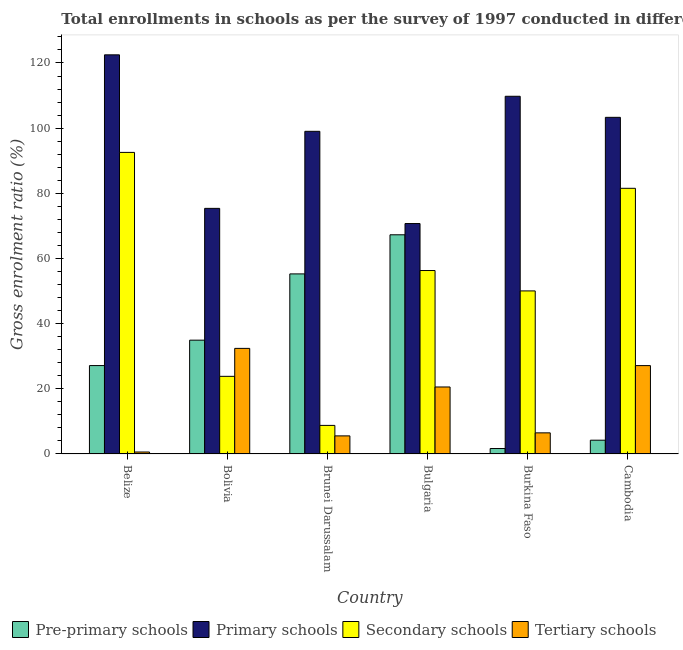How many different coloured bars are there?
Make the answer very short. 4. Are the number of bars per tick equal to the number of legend labels?
Your answer should be very brief. Yes. Are the number of bars on each tick of the X-axis equal?
Your answer should be compact. Yes. What is the label of the 1st group of bars from the left?
Ensure brevity in your answer.  Belize. What is the gross enrolment ratio in primary schools in Cambodia?
Make the answer very short. 103.32. Across all countries, what is the maximum gross enrolment ratio in primary schools?
Offer a very short reply. 122.5. Across all countries, what is the minimum gross enrolment ratio in primary schools?
Your answer should be very brief. 70.72. In which country was the gross enrolment ratio in primary schools maximum?
Your response must be concise. Belize. In which country was the gross enrolment ratio in tertiary schools minimum?
Provide a succinct answer. Belize. What is the total gross enrolment ratio in tertiary schools in the graph?
Offer a terse response. 92.72. What is the difference between the gross enrolment ratio in primary schools in Brunei Darussalam and that in Bulgaria?
Offer a very short reply. 28.3. What is the difference between the gross enrolment ratio in secondary schools in Cambodia and the gross enrolment ratio in pre-primary schools in Bulgaria?
Your response must be concise. 14.26. What is the average gross enrolment ratio in pre-primary schools per country?
Your answer should be very brief. 31.75. What is the difference between the gross enrolment ratio in primary schools and gross enrolment ratio in secondary schools in Brunei Darussalam?
Make the answer very short. 90.25. In how many countries, is the gross enrolment ratio in tertiary schools greater than 40 %?
Offer a terse response. 0. What is the ratio of the gross enrolment ratio in secondary schools in Brunei Darussalam to that in Bulgaria?
Give a very brief answer. 0.16. Is the gross enrolment ratio in secondary schools in Bulgaria less than that in Burkina Faso?
Ensure brevity in your answer.  No. What is the difference between the highest and the second highest gross enrolment ratio in secondary schools?
Your answer should be compact. 11.02. What is the difference between the highest and the lowest gross enrolment ratio in secondary schools?
Give a very brief answer. 83.78. Is the sum of the gross enrolment ratio in tertiary schools in Belize and Bolivia greater than the maximum gross enrolment ratio in primary schools across all countries?
Your response must be concise. No. What does the 2nd bar from the left in Cambodia represents?
Provide a succinct answer. Primary schools. What does the 4th bar from the right in Cambodia represents?
Ensure brevity in your answer.  Pre-primary schools. How many bars are there?
Your answer should be compact. 24. How many countries are there in the graph?
Keep it short and to the point. 6. Where does the legend appear in the graph?
Offer a terse response. Bottom left. What is the title of the graph?
Your response must be concise. Total enrollments in schools as per the survey of 1997 conducted in different countries. What is the label or title of the X-axis?
Keep it short and to the point. Country. What is the label or title of the Y-axis?
Give a very brief answer. Gross enrolment ratio (%). What is the Gross enrolment ratio (%) in Pre-primary schools in Belize?
Your answer should be very brief. 27.13. What is the Gross enrolment ratio (%) in Primary schools in Belize?
Provide a succinct answer. 122.5. What is the Gross enrolment ratio (%) in Secondary schools in Belize?
Provide a succinct answer. 92.55. What is the Gross enrolment ratio (%) in Tertiary schools in Belize?
Make the answer very short. 0.6. What is the Gross enrolment ratio (%) in Pre-primary schools in Bolivia?
Offer a very short reply. 34.93. What is the Gross enrolment ratio (%) in Primary schools in Bolivia?
Provide a succinct answer. 75.38. What is the Gross enrolment ratio (%) of Secondary schools in Bolivia?
Ensure brevity in your answer.  23.83. What is the Gross enrolment ratio (%) of Tertiary schools in Bolivia?
Keep it short and to the point. 32.4. What is the Gross enrolment ratio (%) in Pre-primary schools in Brunei Darussalam?
Provide a succinct answer. 55.27. What is the Gross enrolment ratio (%) of Primary schools in Brunei Darussalam?
Provide a succinct answer. 99.02. What is the Gross enrolment ratio (%) of Secondary schools in Brunei Darussalam?
Provide a short and direct response. 8.77. What is the Gross enrolment ratio (%) in Tertiary schools in Brunei Darussalam?
Ensure brevity in your answer.  5.55. What is the Gross enrolment ratio (%) of Pre-primary schools in Bulgaria?
Your answer should be very brief. 67.27. What is the Gross enrolment ratio (%) of Primary schools in Bulgaria?
Your answer should be very brief. 70.72. What is the Gross enrolment ratio (%) in Secondary schools in Bulgaria?
Your answer should be compact. 56.3. What is the Gross enrolment ratio (%) of Tertiary schools in Bulgaria?
Keep it short and to the point. 20.56. What is the Gross enrolment ratio (%) of Pre-primary schools in Burkina Faso?
Make the answer very short. 1.67. What is the Gross enrolment ratio (%) of Primary schools in Burkina Faso?
Offer a terse response. 109.78. What is the Gross enrolment ratio (%) of Secondary schools in Burkina Faso?
Offer a terse response. 50.04. What is the Gross enrolment ratio (%) in Tertiary schools in Burkina Faso?
Ensure brevity in your answer.  6.48. What is the Gross enrolment ratio (%) of Pre-primary schools in Cambodia?
Offer a very short reply. 4.23. What is the Gross enrolment ratio (%) in Primary schools in Cambodia?
Offer a very short reply. 103.32. What is the Gross enrolment ratio (%) in Secondary schools in Cambodia?
Your response must be concise. 81.53. What is the Gross enrolment ratio (%) in Tertiary schools in Cambodia?
Your response must be concise. 27.12. Across all countries, what is the maximum Gross enrolment ratio (%) in Pre-primary schools?
Your answer should be very brief. 67.27. Across all countries, what is the maximum Gross enrolment ratio (%) in Primary schools?
Offer a terse response. 122.5. Across all countries, what is the maximum Gross enrolment ratio (%) of Secondary schools?
Ensure brevity in your answer.  92.55. Across all countries, what is the maximum Gross enrolment ratio (%) in Tertiary schools?
Your response must be concise. 32.4. Across all countries, what is the minimum Gross enrolment ratio (%) of Pre-primary schools?
Offer a terse response. 1.67. Across all countries, what is the minimum Gross enrolment ratio (%) of Primary schools?
Your response must be concise. 70.72. Across all countries, what is the minimum Gross enrolment ratio (%) in Secondary schools?
Keep it short and to the point. 8.77. Across all countries, what is the minimum Gross enrolment ratio (%) of Tertiary schools?
Provide a succinct answer. 0.6. What is the total Gross enrolment ratio (%) of Pre-primary schools in the graph?
Give a very brief answer. 190.49. What is the total Gross enrolment ratio (%) of Primary schools in the graph?
Provide a succinct answer. 580.73. What is the total Gross enrolment ratio (%) in Secondary schools in the graph?
Offer a very short reply. 313.03. What is the total Gross enrolment ratio (%) of Tertiary schools in the graph?
Offer a terse response. 92.72. What is the difference between the Gross enrolment ratio (%) of Pre-primary schools in Belize and that in Bolivia?
Your answer should be very brief. -7.79. What is the difference between the Gross enrolment ratio (%) of Primary schools in Belize and that in Bolivia?
Your response must be concise. 47.12. What is the difference between the Gross enrolment ratio (%) of Secondary schools in Belize and that in Bolivia?
Provide a succinct answer. 68.73. What is the difference between the Gross enrolment ratio (%) in Tertiary schools in Belize and that in Bolivia?
Your response must be concise. -31.8. What is the difference between the Gross enrolment ratio (%) of Pre-primary schools in Belize and that in Brunei Darussalam?
Keep it short and to the point. -28.13. What is the difference between the Gross enrolment ratio (%) in Primary schools in Belize and that in Brunei Darussalam?
Your response must be concise. 23.48. What is the difference between the Gross enrolment ratio (%) in Secondary schools in Belize and that in Brunei Darussalam?
Provide a short and direct response. 83.78. What is the difference between the Gross enrolment ratio (%) of Tertiary schools in Belize and that in Brunei Darussalam?
Keep it short and to the point. -4.95. What is the difference between the Gross enrolment ratio (%) in Pre-primary schools in Belize and that in Bulgaria?
Make the answer very short. -40.14. What is the difference between the Gross enrolment ratio (%) of Primary schools in Belize and that in Bulgaria?
Give a very brief answer. 51.78. What is the difference between the Gross enrolment ratio (%) of Secondary schools in Belize and that in Bulgaria?
Give a very brief answer. 36.25. What is the difference between the Gross enrolment ratio (%) in Tertiary schools in Belize and that in Bulgaria?
Your response must be concise. -19.96. What is the difference between the Gross enrolment ratio (%) in Pre-primary schools in Belize and that in Burkina Faso?
Give a very brief answer. 25.46. What is the difference between the Gross enrolment ratio (%) of Primary schools in Belize and that in Burkina Faso?
Ensure brevity in your answer.  12.72. What is the difference between the Gross enrolment ratio (%) of Secondary schools in Belize and that in Burkina Faso?
Keep it short and to the point. 42.51. What is the difference between the Gross enrolment ratio (%) of Tertiary schools in Belize and that in Burkina Faso?
Keep it short and to the point. -5.88. What is the difference between the Gross enrolment ratio (%) of Pre-primary schools in Belize and that in Cambodia?
Offer a terse response. 22.91. What is the difference between the Gross enrolment ratio (%) of Primary schools in Belize and that in Cambodia?
Your answer should be very brief. 19.18. What is the difference between the Gross enrolment ratio (%) of Secondary schools in Belize and that in Cambodia?
Give a very brief answer. 11.02. What is the difference between the Gross enrolment ratio (%) in Tertiary schools in Belize and that in Cambodia?
Your answer should be compact. -26.52. What is the difference between the Gross enrolment ratio (%) of Pre-primary schools in Bolivia and that in Brunei Darussalam?
Give a very brief answer. -20.34. What is the difference between the Gross enrolment ratio (%) of Primary schools in Bolivia and that in Brunei Darussalam?
Make the answer very short. -23.64. What is the difference between the Gross enrolment ratio (%) in Secondary schools in Bolivia and that in Brunei Darussalam?
Keep it short and to the point. 15.06. What is the difference between the Gross enrolment ratio (%) of Tertiary schools in Bolivia and that in Brunei Darussalam?
Give a very brief answer. 26.85. What is the difference between the Gross enrolment ratio (%) of Pre-primary schools in Bolivia and that in Bulgaria?
Keep it short and to the point. -32.34. What is the difference between the Gross enrolment ratio (%) of Primary schools in Bolivia and that in Bulgaria?
Make the answer very short. 4.66. What is the difference between the Gross enrolment ratio (%) in Secondary schools in Bolivia and that in Bulgaria?
Offer a very short reply. -32.48. What is the difference between the Gross enrolment ratio (%) of Tertiary schools in Bolivia and that in Bulgaria?
Offer a very short reply. 11.85. What is the difference between the Gross enrolment ratio (%) of Pre-primary schools in Bolivia and that in Burkina Faso?
Your response must be concise. 33.25. What is the difference between the Gross enrolment ratio (%) in Primary schools in Bolivia and that in Burkina Faso?
Your answer should be compact. -34.4. What is the difference between the Gross enrolment ratio (%) in Secondary schools in Bolivia and that in Burkina Faso?
Your answer should be very brief. -26.22. What is the difference between the Gross enrolment ratio (%) of Tertiary schools in Bolivia and that in Burkina Faso?
Keep it short and to the point. 25.92. What is the difference between the Gross enrolment ratio (%) in Pre-primary schools in Bolivia and that in Cambodia?
Your answer should be very brief. 30.7. What is the difference between the Gross enrolment ratio (%) in Primary schools in Bolivia and that in Cambodia?
Offer a very short reply. -27.94. What is the difference between the Gross enrolment ratio (%) in Secondary schools in Bolivia and that in Cambodia?
Make the answer very short. -57.71. What is the difference between the Gross enrolment ratio (%) in Tertiary schools in Bolivia and that in Cambodia?
Provide a short and direct response. 5.28. What is the difference between the Gross enrolment ratio (%) of Pre-primary schools in Brunei Darussalam and that in Bulgaria?
Your response must be concise. -12. What is the difference between the Gross enrolment ratio (%) of Primary schools in Brunei Darussalam and that in Bulgaria?
Your response must be concise. 28.3. What is the difference between the Gross enrolment ratio (%) in Secondary schools in Brunei Darussalam and that in Bulgaria?
Make the answer very short. -47.53. What is the difference between the Gross enrolment ratio (%) of Tertiary schools in Brunei Darussalam and that in Bulgaria?
Make the answer very short. -15.01. What is the difference between the Gross enrolment ratio (%) of Pre-primary schools in Brunei Darussalam and that in Burkina Faso?
Ensure brevity in your answer.  53.59. What is the difference between the Gross enrolment ratio (%) in Primary schools in Brunei Darussalam and that in Burkina Faso?
Make the answer very short. -10.76. What is the difference between the Gross enrolment ratio (%) in Secondary schools in Brunei Darussalam and that in Burkina Faso?
Your response must be concise. -41.27. What is the difference between the Gross enrolment ratio (%) in Tertiary schools in Brunei Darussalam and that in Burkina Faso?
Keep it short and to the point. -0.93. What is the difference between the Gross enrolment ratio (%) of Pre-primary schools in Brunei Darussalam and that in Cambodia?
Offer a very short reply. 51.04. What is the difference between the Gross enrolment ratio (%) of Primary schools in Brunei Darussalam and that in Cambodia?
Your response must be concise. -4.29. What is the difference between the Gross enrolment ratio (%) in Secondary schools in Brunei Darussalam and that in Cambodia?
Offer a very short reply. -72.76. What is the difference between the Gross enrolment ratio (%) in Tertiary schools in Brunei Darussalam and that in Cambodia?
Your answer should be very brief. -21.57. What is the difference between the Gross enrolment ratio (%) of Pre-primary schools in Bulgaria and that in Burkina Faso?
Your response must be concise. 65.6. What is the difference between the Gross enrolment ratio (%) of Primary schools in Bulgaria and that in Burkina Faso?
Keep it short and to the point. -39.06. What is the difference between the Gross enrolment ratio (%) of Secondary schools in Bulgaria and that in Burkina Faso?
Keep it short and to the point. 6.26. What is the difference between the Gross enrolment ratio (%) in Tertiary schools in Bulgaria and that in Burkina Faso?
Provide a short and direct response. 14.08. What is the difference between the Gross enrolment ratio (%) of Pre-primary schools in Bulgaria and that in Cambodia?
Your response must be concise. 63.04. What is the difference between the Gross enrolment ratio (%) of Primary schools in Bulgaria and that in Cambodia?
Your answer should be compact. -32.59. What is the difference between the Gross enrolment ratio (%) of Secondary schools in Bulgaria and that in Cambodia?
Ensure brevity in your answer.  -25.23. What is the difference between the Gross enrolment ratio (%) in Tertiary schools in Bulgaria and that in Cambodia?
Your answer should be very brief. -6.56. What is the difference between the Gross enrolment ratio (%) of Pre-primary schools in Burkina Faso and that in Cambodia?
Offer a very short reply. -2.55. What is the difference between the Gross enrolment ratio (%) in Primary schools in Burkina Faso and that in Cambodia?
Your answer should be very brief. 6.47. What is the difference between the Gross enrolment ratio (%) of Secondary schools in Burkina Faso and that in Cambodia?
Your answer should be compact. -31.49. What is the difference between the Gross enrolment ratio (%) of Tertiary schools in Burkina Faso and that in Cambodia?
Give a very brief answer. -20.64. What is the difference between the Gross enrolment ratio (%) of Pre-primary schools in Belize and the Gross enrolment ratio (%) of Primary schools in Bolivia?
Offer a terse response. -48.25. What is the difference between the Gross enrolment ratio (%) in Pre-primary schools in Belize and the Gross enrolment ratio (%) in Secondary schools in Bolivia?
Make the answer very short. 3.31. What is the difference between the Gross enrolment ratio (%) in Pre-primary schools in Belize and the Gross enrolment ratio (%) in Tertiary schools in Bolivia?
Ensure brevity in your answer.  -5.27. What is the difference between the Gross enrolment ratio (%) in Primary schools in Belize and the Gross enrolment ratio (%) in Secondary schools in Bolivia?
Provide a short and direct response. 98.67. What is the difference between the Gross enrolment ratio (%) of Primary schools in Belize and the Gross enrolment ratio (%) of Tertiary schools in Bolivia?
Provide a short and direct response. 90.1. What is the difference between the Gross enrolment ratio (%) of Secondary schools in Belize and the Gross enrolment ratio (%) of Tertiary schools in Bolivia?
Your response must be concise. 60.15. What is the difference between the Gross enrolment ratio (%) of Pre-primary schools in Belize and the Gross enrolment ratio (%) of Primary schools in Brunei Darussalam?
Provide a succinct answer. -71.89. What is the difference between the Gross enrolment ratio (%) in Pre-primary schools in Belize and the Gross enrolment ratio (%) in Secondary schools in Brunei Darussalam?
Offer a very short reply. 18.36. What is the difference between the Gross enrolment ratio (%) of Pre-primary schools in Belize and the Gross enrolment ratio (%) of Tertiary schools in Brunei Darussalam?
Provide a succinct answer. 21.58. What is the difference between the Gross enrolment ratio (%) in Primary schools in Belize and the Gross enrolment ratio (%) in Secondary schools in Brunei Darussalam?
Your answer should be very brief. 113.73. What is the difference between the Gross enrolment ratio (%) in Primary schools in Belize and the Gross enrolment ratio (%) in Tertiary schools in Brunei Darussalam?
Keep it short and to the point. 116.95. What is the difference between the Gross enrolment ratio (%) of Secondary schools in Belize and the Gross enrolment ratio (%) of Tertiary schools in Brunei Darussalam?
Provide a succinct answer. 87. What is the difference between the Gross enrolment ratio (%) of Pre-primary schools in Belize and the Gross enrolment ratio (%) of Primary schools in Bulgaria?
Offer a terse response. -43.59. What is the difference between the Gross enrolment ratio (%) of Pre-primary schools in Belize and the Gross enrolment ratio (%) of Secondary schools in Bulgaria?
Offer a very short reply. -29.17. What is the difference between the Gross enrolment ratio (%) of Pre-primary schools in Belize and the Gross enrolment ratio (%) of Tertiary schools in Bulgaria?
Your answer should be compact. 6.57. What is the difference between the Gross enrolment ratio (%) of Primary schools in Belize and the Gross enrolment ratio (%) of Secondary schools in Bulgaria?
Offer a very short reply. 66.2. What is the difference between the Gross enrolment ratio (%) in Primary schools in Belize and the Gross enrolment ratio (%) in Tertiary schools in Bulgaria?
Provide a short and direct response. 101.94. What is the difference between the Gross enrolment ratio (%) in Secondary schools in Belize and the Gross enrolment ratio (%) in Tertiary schools in Bulgaria?
Offer a terse response. 72. What is the difference between the Gross enrolment ratio (%) of Pre-primary schools in Belize and the Gross enrolment ratio (%) of Primary schools in Burkina Faso?
Your answer should be compact. -82.65. What is the difference between the Gross enrolment ratio (%) of Pre-primary schools in Belize and the Gross enrolment ratio (%) of Secondary schools in Burkina Faso?
Your answer should be compact. -22.91. What is the difference between the Gross enrolment ratio (%) in Pre-primary schools in Belize and the Gross enrolment ratio (%) in Tertiary schools in Burkina Faso?
Your answer should be compact. 20.65. What is the difference between the Gross enrolment ratio (%) in Primary schools in Belize and the Gross enrolment ratio (%) in Secondary schools in Burkina Faso?
Your answer should be very brief. 72.46. What is the difference between the Gross enrolment ratio (%) in Primary schools in Belize and the Gross enrolment ratio (%) in Tertiary schools in Burkina Faso?
Make the answer very short. 116.02. What is the difference between the Gross enrolment ratio (%) in Secondary schools in Belize and the Gross enrolment ratio (%) in Tertiary schools in Burkina Faso?
Ensure brevity in your answer.  86.07. What is the difference between the Gross enrolment ratio (%) of Pre-primary schools in Belize and the Gross enrolment ratio (%) of Primary schools in Cambodia?
Offer a very short reply. -76.18. What is the difference between the Gross enrolment ratio (%) of Pre-primary schools in Belize and the Gross enrolment ratio (%) of Secondary schools in Cambodia?
Your response must be concise. -54.4. What is the difference between the Gross enrolment ratio (%) in Pre-primary schools in Belize and the Gross enrolment ratio (%) in Tertiary schools in Cambodia?
Your answer should be very brief. 0.01. What is the difference between the Gross enrolment ratio (%) in Primary schools in Belize and the Gross enrolment ratio (%) in Secondary schools in Cambodia?
Provide a short and direct response. 40.97. What is the difference between the Gross enrolment ratio (%) in Primary schools in Belize and the Gross enrolment ratio (%) in Tertiary schools in Cambodia?
Your answer should be very brief. 95.38. What is the difference between the Gross enrolment ratio (%) of Secondary schools in Belize and the Gross enrolment ratio (%) of Tertiary schools in Cambodia?
Keep it short and to the point. 65.43. What is the difference between the Gross enrolment ratio (%) in Pre-primary schools in Bolivia and the Gross enrolment ratio (%) in Primary schools in Brunei Darussalam?
Your answer should be very brief. -64.1. What is the difference between the Gross enrolment ratio (%) of Pre-primary schools in Bolivia and the Gross enrolment ratio (%) of Secondary schools in Brunei Darussalam?
Your response must be concise. 26.16. What is the difference between the Gross enrolment ratio (%) of Pre-primary schools in Bolivia and the Gross enrolment ratio (%) of Tertiary schools in Brunei Darussalam?
Give a very brief answer. 29.38. What is the difference between the Gross enrolment ratio (%) of Primary schools in Bolivia and the Gross enrolment ratio (%) of Secondary schools in Brunei Darussalam?
Give a very brief answer. 66.61. What is the difference between the Gross enrolment ratio (%) in Primary schools in Bolivia and the Gross enrolment ratio (%) in Tertiary schools in Brunei Darussalam?
Keep it short and to the point. 69.83. What is the difference between the Gross enrolment ratio (%) in Secondary schools in Bolivia and the Gross enrolment ratio (%) in Tertiary schools in Brunei Darussalam?
Ensure brevity in your answer.  18.28. What is the difference between the Gross enrolment ratio (%) in Pre-primary schools in Bolivia and the Gross enrolment ratio (%) in Primary schools in Bulgaria?
Your answer should be compact. -35.79. What is the difference between the Gross enrolment ratio (%) of Pre-primary schools in Bolivia and the Gross enrolment ratio (%) of Secondary schools in Bulgaria?
Your answer should be very brief. -21.37. What is the difference between the Gross enrolment ratio (%) in Pre-primary schools in Bolivia and the Gross enrolment ratio (%) in Tertiary schools in Bulgaria?
Your response must be concise. 14.37. What is the difference between the Gross enrolment ratio (%) in Primary schools in Bolivia and the Gross enrolment ratio (%) in Secondary schools in Bulgaria?
Offer a very short reply. 19.08. What is the difference between the Gross enrolment ratio (%) in Primary schools in Bolivia and the Gross enrolment ratio (%) in Tertiary schools in Bulgaria?
Your response must be concise. 54.82. What is the difference between the Gross enrolment ratio (%) in Secondary schools in Bolivia and the Gross enrolment ratio (%) in Tertiary schools in Bulgaria?
Your answer should be very brief. 3.27. What is the difference between the Gross enrolment ratio (%) in Pre-primary schools in Bolivia and the Gross enrolment ratio (%) in Primary schools in Burkina Faso?
Offer a terse response. -74.86. What is the difference between the Gross enrolment ratio (%) of Pre-primary schools in Bolivia and the Gross enrolment ratio (%) of Secondary schools in Burkina Faso?
Make the answer very short. -15.12. What is the difference between the Gross enrolment ratio (%) of Pre-primary schools in Bolivia and the Gross enrolment ratio (%) of Tertiary schools in Burkina Faso?
Offer a terse response. 28.45. What is the difference between the Gross enrolment ratio (%) in Primary schools in Bolivia and the Gross enrolment ratio (%) in Secondary schools in Burkina Faso?
Give a very brief answer. 25.34. What is the difference between the Gross enrolment ratio (%) of Primary schools in Bolivia and the Gross enrolment ratio (%) of Tertiary schools in Burkina Faso?
Provide a succinct answer. 68.9. What is the difference between the Gross enrolment ratio (%) of Secondary schools in Bolivia and the Gross enrolment ratio (%) of Tertiary schools in Burkina Faso?
Provide a short and direct response. 17.35. What is the difference between the Gross enrolment ratio (%) of Pre-primary schools in Bolivia and the Gross enrolment ratio (%) of Primary schools in Cambodia?
Ensure brevity in your answer.  -68.39. What is the difference between the Gross enrolment ratio (%) in Pre-primary schools in Bolivia and the Gross enrolment ratio (%) in Secondary schools in Cambodia?
Provide a succinct answer. -46.61. What is the difference between the Gross enrolment ratio (%) of Pre-primary schools in Bolivia and the Gross enrolment ratio (%) of Tertiary schools in Cambodia?
Offer a terse response. 7.8. What is the difference between the Gross enrolment ratio (%) in Primary schools in Bolivia and the Gross enrolment ratio (%) in Secondary schools in Cambodia?
Keep it short and to the point. -6.15. What is the difference between the Gross enrolment ratio (%) of Primary schools in Bolivia and the Gross enrolment ratio (%) of Tertiary schools in Cambodia?
Ensure brevity in your answer.  48.26. What is the difference between the Gross enrolment ratio (%) in Secondary schools in Bolivia and the Gross enrolment ratio (%) in Tertiary schools in Cambodia?
Offer a very short reply. -3.3. What is the difference between the Gross enrolment ratio (%) in Pre-primary schools in Brunei Darussalam and the Gross enrolment ratio (%) in Primary schools in Bulgaria?
Keep it short and to the point. -15.46. What is the difference between the Gross enrolment ratio (%) of Pre-primary schools in Brunei Darussalam and the Gross enrolment ratio (%) of Secondary schools in Bulgaria?
Offer a very short reply. -1.04. What is the difference between the Gross enrolment ratio (%) in Pre-primary schools in Brunei Darussalam and the Gross enrolment ratio (%) in Tertiary schools in Bulgaria?
Offer a terse response. 34.71. What is the difference between the Gross enrolment ratio (%) in Primary schools in Brunei Darussalam and the Gross enrolment ratio (%) in Secondary schools in Bulgaria?
Ensure brevity in your answer.  42.72. What is the difference between the Gross enrolment ratio (%) of Primary schools in Brunei Darussalam and the Gross enrolment ratio (%) of Tertiary schools in Bulgaria?
Ensure brevity in your answer.  78.46. What is the difference between the Gross enrolment ratio (%) of Secondary schools in Brunei Darussalam and the Gross enrolment ratio (%) of Tertiary schools in Bulgaria?
Provide a short and direct response. -11.79. What is the difference between the Gross enrolment ratio (%) of Pre-primary schools in Brunei Darussalam and the Gross enrolment ratio (%) of Primary schools in Burkina Faso?
Provide a succinct answer. -54.52. What is the difference between the Gross enrolment ratio (%) of Pre-primary schools in Brunei Darussalam and the Gross enrolment ratio (%) of Secondary schools in Burkina Faso?
Your response must be concise. 5.22. What is the difference between the Gross enrolment ratio (%) in Pre-primary schools in Brunei Darussalam and the Gross enrolment ratio (%) in Tertiary schools in Burkina Faso?
Give a very brief answer. 48.79. What is the difference between the Gross enrolment ratio (%) of Primary schools in Brunei Darussalam and the Gross enrolment ratio (%) of Secondary schools in Burkina Faso?
Provide a succinct answer. 48.98. What is the difference between the Gross enrolment ratio (%) of Primary schools in Brunei Darussalam and the Gross enrolment ratio (%) of Tertiary schools in Burkina Faso?
Give a very brief answer. 92.54. What is the difference between the Gross enrolment ratio (%) in Secondary schools in Brunei Darussalam and the Gross enrolment ratio (%) in Tertiary schools in Burkina Faso?
Offer a terse response. 2.29. What is the difference between the Gross enrolment ratio (%) of Pre-primary schools in Brunei Darussalam and the Gross enrolment ratio (%) of Primary schools in Cambodia?
Make the answer very short. -48.05. What is the difference between the Gross enrolment ratio (%) in Pre-primary schools in Brunei Darussalam and the Gross enrolment ratio (%) in Secondary schools in Cambodia?
Ensure brevity in your answer.  -26.27. What is the difference between the Gross enrolment ratio (%) in Pre-primary schools in Brunei Darussalam and the Gross enrolment ratio (%) in Tertiary schools in Cambodia?
Keep it short and to the point. 28.14. What is the difference between the Gross enrolment ratio (%) in Primary schools in Brunei Darussalam and the Gross enrolment ratio (%) in Secondary schools in Cambodia?
Offer a very short reply. 17.49. What is the difference between the Gross enrolment ratio (%) of Primary schools in Brunei Darussalam and the Gross enrolment ratio (%) of Tertiary schools in Cambodia?
Give a very brief answer. 71.9. What is the difference between the Gross enrolment ratio (%) of Secondary schools in Brunei Darussalam and the Gross enrolment ratio (%) of Tertiary schools in Cambodia?
Ensure brevity in your answer.  -18.35. What is the difference between the Gross enrolment ratio (%) of Pre-primary schools in Bulgaria and the Gross enrolment ratio (%) of Primary schools in Burkina Faso?
Your response must be concise. -42.51. What is the difference between the Gross enrolment ratio (%) in Pre-primary schools in Bulgaria and the Gross enrolment ratio (%) in Secondary schools in Burkina Faso?
Provide a succinct answer. 17.23. What is the difference between the Gross enrolment ratio (%) in Pre-primary schools in Bulgaria and the Gross enrolment ratio (%) in Tertiary schools in Burkina Faso?
Your answer should be compact. 60.79. What is the difference between the Gross enrolment ratio (%) in Primary schools in Bulgaria and the Gross enrolment ratio (%) in Secondary schools in Burkina Faso?
Keep it short and to the point. 20.68. What is the difference between the Gross enrolment ratio (%) in Primary schools in Bulgaria and the Gross enrolment ratio (%) in Tertiary schools in Burkina Faso?
Your answer should be compact. 64.24. What is the difference between the Gross enrolment ratio (%) of Secondary schools in Bulgaria and the Gross enrolment ratio (%) of Tertiary schools in Burkina Faso?
Make the answer very short. 49.82. What is the difference between the Gross enrolment ratio (%) in Pre-primary schools in Bulgaria and the Gross enrolment ratio (%) in Primary schools in Cambodia?
Your response must be concise. -36.05. What is the difference between the Gross enrolment ratio (%) of Pre-primary schools in Bulgaria and the Gross enrolment ratio (%) of Secondary schools in Cambodia?
Provide a short and direct response. -14.26. What is the difference between the Gross enrolment ratio (%) in Pre-primary schools in Bulgaria and the Gross enrolment ratio (%) in Tertiary schools in Cambodia?
Offer a very short reply. 40.15. What is the difference between the Gross enrolment ratio (%) of Primary schools in Bulgaria and the Gross enrolment ratio (%) of Secondary schools in Cambodia?
Offer a terse response. -10.81. What is the difference between the Gross enrolment ratio (%) in Primary schools in Bulgaria and the Gross enrolment ratio (%) in Tertiary schools in Cambodia?
Your response must be concise. 43.6. What is the difference between the Gross enrolment ratio (%) in Secondary schools in Bulgaria and the Gross enrolment ratio (%) in Tertiary schools in Cambodia?
Ensure brevity in your answer.  29.18. What is the difference between the Gross enrolment ratio (%) of Pre-primary schools in Burkina Faso and the Gross enrolment ratio (%) of Primary schools in Cambodia?
Make the answer very short. -101.64. What is the difference between the Gross enrolment ratio (%) of Pre-primary schools in Burkina Faso and the Gross enrolment ratio (%) of Secondary schools in Cambodia?
Your answer should be very brief. -79.86. What is the difference between the Gross enrolment ratio (%) of Pre-primary schools in Burkina Faso and the Gross enrolment ratio (%) of Tertiary schools in Cambodia?
Offer a terse response. -25.45. What is the difference between the Gross enrolment ratio (%) in Primary schools in Burkina Faso and the Gross enrolment ratio (%) in Secondary schools in Cambodia?
Give a very brief answer. 28.25. What is the difference between the Gross enrolment ratio (%) in Primary schools in Burkina Faso and the Gross enrolment ratio (%) in Tertiary schools in Cambodia?
Ensure brevity in your answer.  82.66. What is the difference between the Gross enrolment ratio (%) in Secondary schools in Burkina Faso and the Gross enrolment ratio (%) in Tertiary schools in Cambodia?
Give a very brief answer. 22.92. What is the average Gross enrolment ratio (%) of Pre-primary schools per country?
Give a very brief answer. 31.75. What is the average Gross enrolment ratio (%) in Primary schools per country?
Ensure brevity in your answer.  96.79. What is the average Gross enrolment ratio (%) in Secondary schools per country?
Offer a very short reply. 52.17. What is the average Gross enrolment ratio (%) of Tertiary schools per country?
Offer a very short reply. 15.45. What is the difference between the Gross enrolment ratio (%) of Pre-primary schools and Gross enrolment ratio (%) of Primary schools in Belize?
Provide a short and direct response. -95.37. What is the difference between the Gross enrolment ratio (%) of Pre-primary schools and Gross enrolment ratio (%) of Secondary schools in Belize?
Your answer should be very brief. -65.42. What is the difference between the Gross enrolment ratio (%) of Pre-primary schools and Gross enrolment ratio (%) of Tertiary schools in Belize?
Provide a short and direct response. 26.53. What is the difference between the Gross enrolment ratio (%) in Primary schools and Gross enrolment ratio (%) in Secondary schools in Belize?
Provide a succinct answer. 29.95. What is the difference between the Gross enrolment ratio (%) in Primary schools and Gross enrolment ratio (%) in Tertiary schools in Belize?
Your response must be concise. 121.9. What is the difference between the Gross enrolment ratio (%) in Secondary schools and Gross enrolment ratio (%) in Tertiary schools in Belize?
Provide a succinct answer. 91.95. What is the difference between the Gross enrolment ratio (%) of Pre-primary schools and Gross enrolment ratio (%) of Primary schools in Bolivia?
Offer a terse response. -40.45. What is the difference between the Gross enrolment ratio (%) in Pre-primary schools and Gross enrolment ratio (%) in Secondary schools in Bolivia?
Offer a very short reply. 11.1. What is the difference between the Gross enrolment ratio (%) in Pre-primary schools and Gross enrolment ratio (%) in Tertiary schools in Bolivia?
Offer a terse response. 2.52. What is the difference between the Gross enrolment ratio (%) in Primary schools and Gross enrolment ratio (%) in Secondary schools in Bolivia?
Offer a terse response. 51.55. What is the difference between the Gross enrolment ratio (%) in Primary schools and Gross enrolment ratio (%) in Tertiary schools in Bolivia?
Give a very brief answer. 42.98. What is the difference between the Gross enrolment ratio (%) of Secondary schools and Gross enrolment ratio (%) of Tertiary schools in Bolivia?
Provide a succinct answer. -8.58. What is the difference between the Gross enrolment ratio (%) in Pre-primary schools and Gross enrolment ratio (%) in Primary schools in Brunei Darussalam?
Offer a very short reply. -43.76. What is the difference between the Gross enrolment ratio (%) in Pre-primary schools and Gross enrolment ratio (%) in Secondary schools in Brunei Darussalam?
Provide a succinct answer. 46.49. What is the difference between the Gross enrolment ratio (%) of Pre-primary schools and Gross enrolment ratio (%) of Tertiary schools in Brunei Darussalam?
Your answer should be compact. 49.71. What is the difference between the Gross enrolment ratio (%) in Primary schools and Gross enrolment ratio (%) in Secondary schools in Brunei Darussalam?
Your response must be concise. 90.25. What is the difference between the Gross enrolment ratio (%) of Primary schools and Gross enrolment ratio (%) of Tertiary schools in Brunei Darussalam?
Keep it short and to the point. 93.47. What is the difference between the Gross enrolment ratio (%) in Secondary schools and Gross enrolment ratio (%) in Tertiary schools in Brunei Darussalam?
Offer a very short reply. 3.22. What is the difference between the Gross enrolment ratio (%) of Pre-primary schools and Gross enrolment ratio (%) of Primary schools in Bulgaria?
Your answer should be very brief. -3.45. What is the difference between the Gross enrolment ratio (%) of Pre-primary schools and Gross enrolment ratio (%) of Secondary schools in Bulgaria?
Provide a short and direct response. 10.97. What is the difference between the Gross enrolment ratio (%) in Pre-primary schools and Gross enrolment ratio (%) in Tertiary schools in Bulgaria?
Your answer should be very brief. 46.71. What is the difference between the Gross enrolment ratio (%) of Primary schools and Gross enrolment ratio (%) of Secondary schools in Bulgaria?
Your response must be concise. 14.42. What is the difference between the Gross enrolment ratio (%) of Primary schools and Gross enrolment ratio (%) of Tertiary schools in Bulgaria?
Give a very brief answer. 50.16. What is the difference between the Gross enrolment ratio (%) in Secondary schools and Gross enrolment ratio (%) in Tertiary schools in Bulgaria?
Your answer should be compact. 35.74. What is the difference between the Gross enrolment ratio (%) of Pre-primary schools and Gross enrolment ratio (%) of Primary schools in Burkina Faso?
Provide a succinct answer. -108.11. What is the difference between the Gross enrolment ratio (%) in Pre-primary schools and Gross enrolment ratio (%) in Secondary schools in Burkina Faso?
Your response must be concise. -48.37. What is the difference between the Gross enrolment ratio (%) of Pre-primary schools and Gross enrolment ratio (%) of Tertiary schools in Burkina Faso?
Ensure brevity in your answer.  -4.81. What is the difference between the Gross enrolment ratio (%) in Primary schools and Gross enrolment ratio (%) in Secondary schools in Burkina Faso?
Offer a terse response. 59.74. What is the difference between the Gross enrolment ratio (%) of Primary schools and Gross enrolment ratio (%) of Tertiary schools in Burkina Faso?
Give a very brief answer. 103.3. What is the difference between the Gross enrolment ratio (%) in Secondary schools and Gross enrolment ratio (%) in Tertiary schools in Burkina Faso?
Provide a short and direct response. 43.56. What is the difference between the Gross enrolment ratio (%) of Pre-primary schools and Gross enrolment ratio (%) of Primary schools in Cambodia?
Ensure brevity in your answer.  -99.09. What is the difference between the Gross enrolment ratio (%) of Pre-primary schools and Gross enrolment ratio (%) of Secondary schools in Cambodia?
Offer a terse response. -77.31. What is the difference between the Gross enrolment ratio (%) of Pre-primary schools and Gross enrolment ratio (%) of Tertiary schools in Cambodia?
Make the answer very short. -22.9. What is the difference between the Gross enrolment ratio (%) of Primary schools and Gross enrolment ratio (%) of Secondary schools in Cambodia?
Make the answer very short. 21.78. What is the difference between the Gross enrolment ratio (%) in Primary schools and Gross enrolment ratio (%) in Tertiary schools in Cambodia?
Make the answer very short. 76.19. What is the difference between the Gross enrolment ratio (%) of Secondary schools and Gross enrolment ratio (%) of Tertiary schools in Cambodia?
Your answer should be compact. 54.41. What is the ratio of the Gross enrolment ratio (%) of Pre-primary schools in Belize to that in Bolivia?
Your response must be concise. 0.78. What is the ratio of the Gross enrolment ratio (%) in Primary schools in Belize to that in Bolivia?
Keep it short and to the point. 1.63. What is the ratio of the Gross enrolment ratio (%) of Secondary schools in Belize to that in Bolivia?
Make the answer very short. 3.88. What is the ratio of the Gross enrolment ratio (%) of Tertiary schools in Belize to that in Bolivia?
Provide a succinct answer. 0.02. What is the ratio of the Gross enrolment ratio (%) in Pre-primary schools in Belize to that in Brunei Darussalam?
Make the answer very short. 0.49. What is the ratio of the Gross enrolment ratio (%) in Primary schools in Belize to that in Brunei Darussalam?
Provide a succinct answer. 1.24. What is the ratio of the Gross enrolment ratio (%) of Secondary schools in Belize to that in Brunei Darussalam?
Offer a terse response. 10.55. What is the ratio of the Gross enrolment ratio (%) of Tertiary schools in Belize to that in Brunei Darussalam?
Your answer should be compact. 0.11. What is the ratio of the Gross enrolment ratio (%) in Pre-primary schools in Belize to that in Bulgaria?
Provide a succinct answer. 0.4. What is the ratio of the Gross enrolment ratio (%) in Primary schools in Belize to that in Bulgaria?
Make the answer very short. 1.73. What is the ratio of the Gross enrolment ratio (%) in Secondary schools in Belize to that in Bulgaria?
Ensure brevity in your answer.  1.64. What is the ratio of the Gross enrolment ratio (%) in Tertiary schools in Belize to that in Bulgaria?
Make the answer very short. 0.03. What is the ratio of the Gross enrolment ratio (%) in Pre-primary schools in Belize to that in Burkina Faso?
Keep it short and to the point. 16.23. What is the ratio of the Gross enrolment ratio (%) of Primary schools in Belize to that in Burkina Faso?
Offer a very short reply. 1.12. What is the ratio of the Gross enrolment ratio (%) of Secondary schools in Belize to that in Burkina Faso?
Offer a very short reply. 1.85. What is the ratio of the Gross enrolment ratio (%) of Tertiary schools in Belize to that in Burkina Faso?
Offer a very short reply. 0.09. What is the ratio of the Gross enrolment ratio (%) in Pre-primary schools in Belize to that in Cambodia?
Provide a short and direct response. 6.42. What is the ratio of the Gross enrolment ratio (%) of Primary schools in Belize to that in Cambodia?
Keep it short and to the point. 1.19. What is the ratio of the Gross enrolment ratio (%) in Secondary schools in Belize to that in Cambodia?
Offer a terse response. 1.14. What is the ratio of the Gross enrolment ratio (%) in Tertiary schools in Belize to that in Cambodia?
Provide a succinct answer. 0.02. What is the ratio of the Gross enrolment ratio (%) of Pre-primary schools in Bolivia to that in Brunei Darussalam?
Ensure brevity in your answer.  0.63. What is the ratio of the Gross enrolment ratio (%) in Primary schools in Bolivia to that in Brunei Darussalam?
Keep it short and to the point. 0.76. What is the ratio of the Gross enrolment ratio (%) of Secondary schools in Bolivia to that in Brunei Darussalam?
Offer a very short reply. 2.72. What is the ratio of the Gross enrolment ratio (%) in Tertiary schools in Bolivia to that in Brunei Darussalam?
Offer a terse response. 5.84. What is the ratio of the Gross enrolment ratio (%) in Pre-primary schools in Bolivia to that in Bulgaria?
Ensure brevity in your answer.  0.52. What is the ratio of the Gross enrolment ratio (%) of Primary schools in Bolivia to that in Bulgaria?
Provide a succinct answer. 1.07. What is the ratio of the Gross enrolment ratio (%) of Secondary schools in Bolivia to that in Bulgaria?
Your answer should be very brief. 0.42. What is the ratio of the Gross enrolment ratio (%) in Tertiary schools in Bolivia to that in Bulgaria?
Your response must be concise. 1.58. What is the ratio of the Gross enrolment ratio (%) of Pre-primary schools in Bolivia to that in Burkina Faso?
Provide a short and direct response. 20.89. What is the ratio of the Gross enrolment ratio (%) in Primary schools in Bolivia to that in Burkina Faso?
Your answer should be compact. 0.69. What is the ratio of the Gross enrolment ratio (%) of Secondary schools in Bolivia to that in Burkina Faso?
Your response must be concise. 0.48. What is the ratio of the Gross enrolment ratio (%) of Tertiary schools in Bolivia to that in Burkina Faso?
Give a very brief answer. 5. What is the ratio of the Gross enrolment ratio (%) in Pre-primary schools in Bolivia to that in Cambodia?
Your response must be concise. 8.26. What is the ratio of the Gross enrolment ratio (%) in Primary schools in Bolivia to that in Cambodia?
Offer a very short reply. 0.73. What is the ratio of the Gross enrolment ratio (%) of Secondary schools in Bolivia to that in Cambodia?
Your response must be concise. 0.29. What is the ratio of the Gross enrolment ratio (%) of Tertiary schools in Bolivia to that in Cambodia?
Your answer should be very brief. 1.19. What is the ratio of the Gross enrolment ratio (%) of Pre-primary schools in Brunei Darussalam to that in Bulgaria?
Your response must be concise. 0.82. What is the ratio of the Gross enrolment ratio (%) of Primary schools in Brunei Darussalam to that in Bulgaria?
Give a very brief answer. 1.4. What is the ratio of the Gross enrolment ratio (%) of Secondary schools in Brunei Darussalam to that in Bulgaria?
Make the answer very short. 0.16. What is the ratio of the Gross enrolment ratio (%) of Tertiary schools in Brunei Darussalam to that in Bulgaria?
Offer a very short reply. 0.27. What is the ratio of the Gross enrolment ratio (%) in Pre-primary schools in Brunei Darussalam to that in Burkina Faso?
Your answer should be very brief. 33.05. What is the ratio of the Gross enrolment ratio (%) of Primary schools in Brunei Darussalam to that in Burkina Faso?
Offer a terse response. 0.9. What is the ratio of the Gross enrolment ratio (%) of Secondary schools in Brunei Darussalam to that in Burkina Faso?
Offer a very short reply. 0.18. What is the ratio of the Gross enrolment ratio (%) of Tertiary schools in Brunei Darussalam to that in Burkina Faso?
Give a very brief answer. 0.86. What is the ratio of the Gross enrolment ratio (%) in Pre-primary schools in Brunei Darussalam to that in Cambodia?
Your response must be concise. 13.07. What is the ratio of the Gross enrolment ratio (%) in Primary schools in Brunei Darussalam to that in Cambodia?
Offer a very short reply. 0.96. What is the ratio of the Gross enrolment ratio (%) in Secondary schools in Brunei Darussalam to that in Cambodia?
Provide a succinct answer. 0.11. What is the ratio of the Gross enrolment ratio (%) of Tertiary schools in Brunei Darussalam to that in Cambodia?
Give a very brief answer. 0.2. What is the ratio of the Gross enrolment ratio (%) in Pre-primary schools in Bulgaria to that in Burkina Faso?
Your answer should be very brief. 40.23. What is the ratio of the Gross enrolment ratio (%) in Primary schools in Bulgaria to that in Burkina Faso?
Ensure brevity in your answer.  0.64. What is the ratio of the Gross enrolment ratio (%) in Secondary schools in Bulgaria to that in Burkina Faso?
Keep it short and to the point. 1.13. What is the ratio of the Gross enrolment ratio (%) in Tertiary schools in Bulgaria to that in Burkina Faso?
Your response must be concise. 3.17. What is the ratio of the Gross enrolment ratio (%) of Pre-primary schools in Bulgaria to that in Cambodia?
Your response must be concise. 15.91. What is the ratio of the Gross enrolment ratio (%) of Primary schools in Bulgaria to that in Cambodia?
Your response must be concise. 0.68. What is the ratio of the Gross enrolment ratio (%) of Secondary schools in Bulgaria to that in Cambodia?
Offer a terse response. 0.69. What is the ratio of the Gross enrolment ratio (%) in Tertiary schools in Bulgaria to that in Cambodia?
Keep it short and to the point. 0.76. What is the ratio of the Gross enrolment ratio (%) of Pre-primary schools in Burkina Faso to that in Cambodia?
Make the answer very short. 0.4. What is the ratio of the Gross enrolment ratio (%) in Primary schools in Burkina Faso to that in Cambodia?
Keep it short and to the point. 1.06. What is the ratio of the Gross enrolment ratio (%) of Secondary schools in Burkina Faso to that in Cambodia?
Your answer should be compact. 0.61. What is the ratio of the Gross enrolment ratio (%) of Tertiary schools in Burkina Faso to that in Cambodia?
Offer a terse response. 0.24. What is the difference between the highest and the second highest Gross enrolment ratio (%) of Pre-primary schools?
Your answer should be very brief. 12. What is the difference between the highest and the second highest Gross enrolment ratio (%) of Primary schools?
Ensure brevity in your answer.  12.72. What is the difference between the highest and the second highest Gross enrolment ratio (%) of Secondary schools?
Your response must be concise. 11.02. What is the difference between the highest and the second highest Gross enrolment ratio (%) in Tertiary schools?
Provide a short and direct response. 5.28. What is the difference between the highest and the lowest Gross enrolment ratio (%) in Pre-primary schools?
Ensure brevity in your answer.  65.6. What is the difference between the highest and the lowest Gross enrolment ratio (%) of Primary schools?
Make the answer very short. 51.78. What is the difference between the highest and the lowest Gross enrolment ratio (%) in Secondary schools?
Your answer should be very brief. 83.78. What is the difference between the highest and the lowest Gross enrolment ratio (%) in Tertiary schools?
Provide a succinct answer. 31.8. 